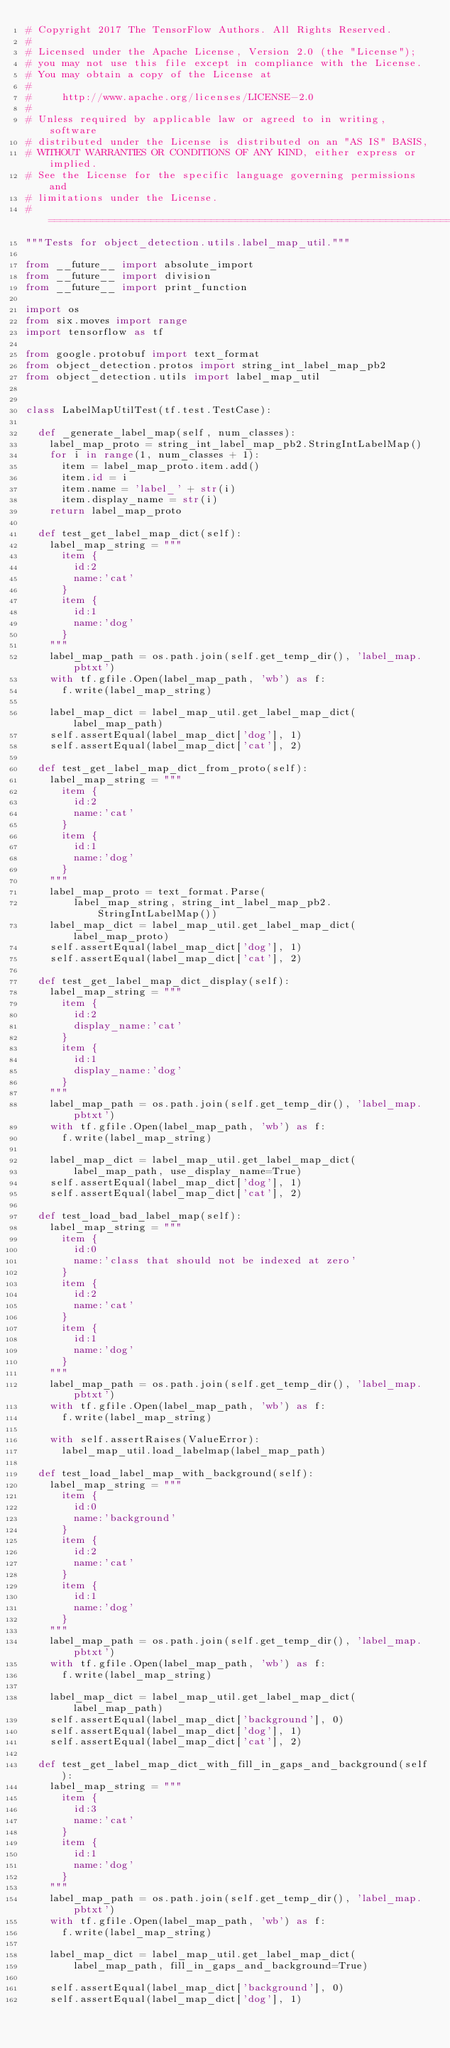<code> <loc_0><loc_0><loc_500><loc_500><_Python_># Copyright 2017 The TensorFlow Authors. All Rights Reserved.
#
# Licensed under the Apache License, Version 2.0 (the "License");
# you may not use this file except in compliance with the License.
# You may obtain a copy of the License at
#
#     http://www.apache.org/licenses/LICENSE-2.0
#
# Unless required by applicable law or agreed to in writing, software
# distributed under the License is distributed on an "AS IS" BASIS,
# WITHOUT WARRANTIES OR CONDITIONS OF ANY KIND, either express or implied.
# See the License for the specific language governing permissions and
# limitations under the License.
# ==============================================================================
"""Tests for object_detection.utils.label_map_util."""

from __future__ import absolute_import
from __future__ import division
from __future__ import print_function

import os
from six.moves import range
import tensorflow as tf

from google.protobuf import text_format
from object_detection.protos import string_int_label_map_pb2
from object_detection.utils import label_map_util


class LabelMapUtilTest(tf.test.TestCase):

  def _generate_label_map(self, num_classes):
    label_map_proto = string_int_label_map_pb2.StringIntLabelMap()
    for i in range(1, num_classes + 1):
      item = label_map_proto.item.add()
      item.id = i
      item.name = 'label_' + str(i)
      item.display_name = str(i)
    return label_map_proto

  def test_get_label_map_dict(self):
    label_map_string = """
      item {
        id:2
        name:'cat'
      }
      item {
        id:1
        name:'dog'
      }
    """
    label_map_path = os.path.join(self.get_temp_dir(), 'label_map.pbtxt')
    with tf.gfile.Open(label_map_path, 'wb') as f:
      f.write(label_map_string)

    label_map_dict = label_map_util.get_label_map_dict(label_map_path)
    self.assertEqual(label_map_dict['dog'], 1)
    self.assertEqual(label_map_dict['cat'], 2)

  def test_get_label_map_dict_from_proto(self):
    label_map_string = """
      item {
        id:2
        name:'cat'
      }
      item {
        id:1
        name:'dog'
      }
    """
    label_map_proto = text_format.Parse(
        label_map_string, string_int_label_map_pb2.StringIntLabelMap())
    label_map_dict = label_map_util.get_label_map_dict(label_map_proto)
    self.assertEqual(label_map_dict['dog'], 1)
    self.assertEqual(label_map_dict['cat'], 2)

  def test_get_label_map_dict_display(self):
    label_map_string = """
      item {
        id:2
        display_name:'cat'
      }
      item {
        id:1
        display_name:'dog'
      }
    """
    label_map_path = os.path.join(self.get_temp_dir(), 'label_map.pbtxt')
    with tf.gfile.Open(label_map_path, 'wb') as f:
      f.write(label_map_string)

    label_map_dict = label_map_util.get_label_map_dict(
        label_map_path, use_display_name=True)
    self.assertEqual(label_map_dict['dog'], 1)
    self.assertEqual(label_map_dict['cat'], 2)

  def test_load_bad_label_map(self):
    label_map_string = """
      item {
        id:0
        name:'class that should not be indexed at zero'
      }
      item {
        id:2
        name:'cat'
      }
      item {
        id:1
        name:'dog'
      }
    """
    label_map_path = os.path.join(self.get_temp_dir(), 'label_map.pbtxt')
    with tf.gfile.Open(label_map_path, 'wb') as f:
      f.write(label_map_string)

    with self.assertRaises(ValueError):
      label_map_util.load_labelmap(label_map_path)

  def test_load_label_map_with_background(self):
    label_map_string = """
      item {
        id:0
        name:'background'
      }
      item {
        id:2
        name:'cat'
      }
      item {
        id:1
        name:'dog'
      }
    """
    label_map_path = os.path.join(self.get_temp_dir(), 'label_map.pbtxt')
    with tf.gfile.Open(label_map_path, 'wb') as f:
      f.write(label_map_string)

    label_map_dict = label_map_util.get_label_map_dict(label_map_path)
    self.assertEqual(label_map_dict['background'], 0)
    self.assertEqual(label_map_dict['dog'], 1)
    self.assertEqual(label_map_dict['cat'], 2)

  def test_get_label_map_dict_with_fill_in_gaps_and_background(self):
    label_map_string = """
      item {
        id:3
        name:'cat'
      }
      item {
        id:1
        name:'dog'
      }
    """
    label_map_path = os.path.join(self.get_temp_dir(), 'label_map.pbtxt')
    with tf.gfile.Open(label_map_path, 'wb') as f:
      f.write(label_map_string)

    label_map_dict = label_map_util.get_label_map_dict(
        label_map_path, fill_in_gaps_and_background=True)

    self.assertEqual(label_map_dict['background'], 0)
    self.assertEqual(label_map_dict['dog'], 1)</code> 